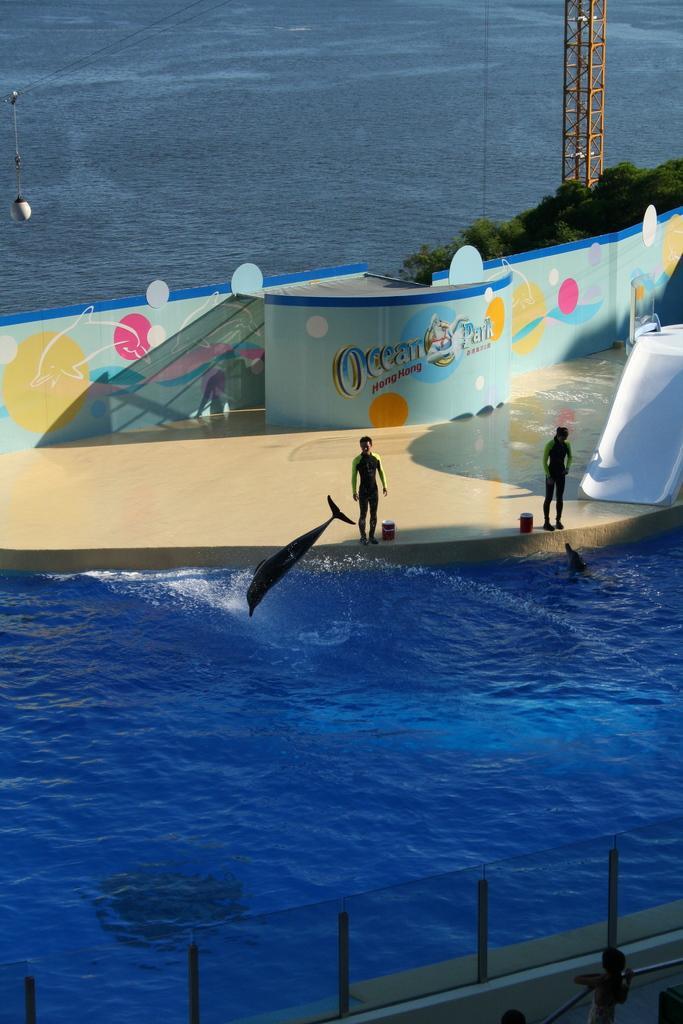Please provide a concise description of this image. This is a swimming pool. A dolphin is jumping in the water. Two persons are standing on the side of the pool. In the background there is a banner, trees, water, stand and a rope with a light. In the front there is a wall with pillars. 